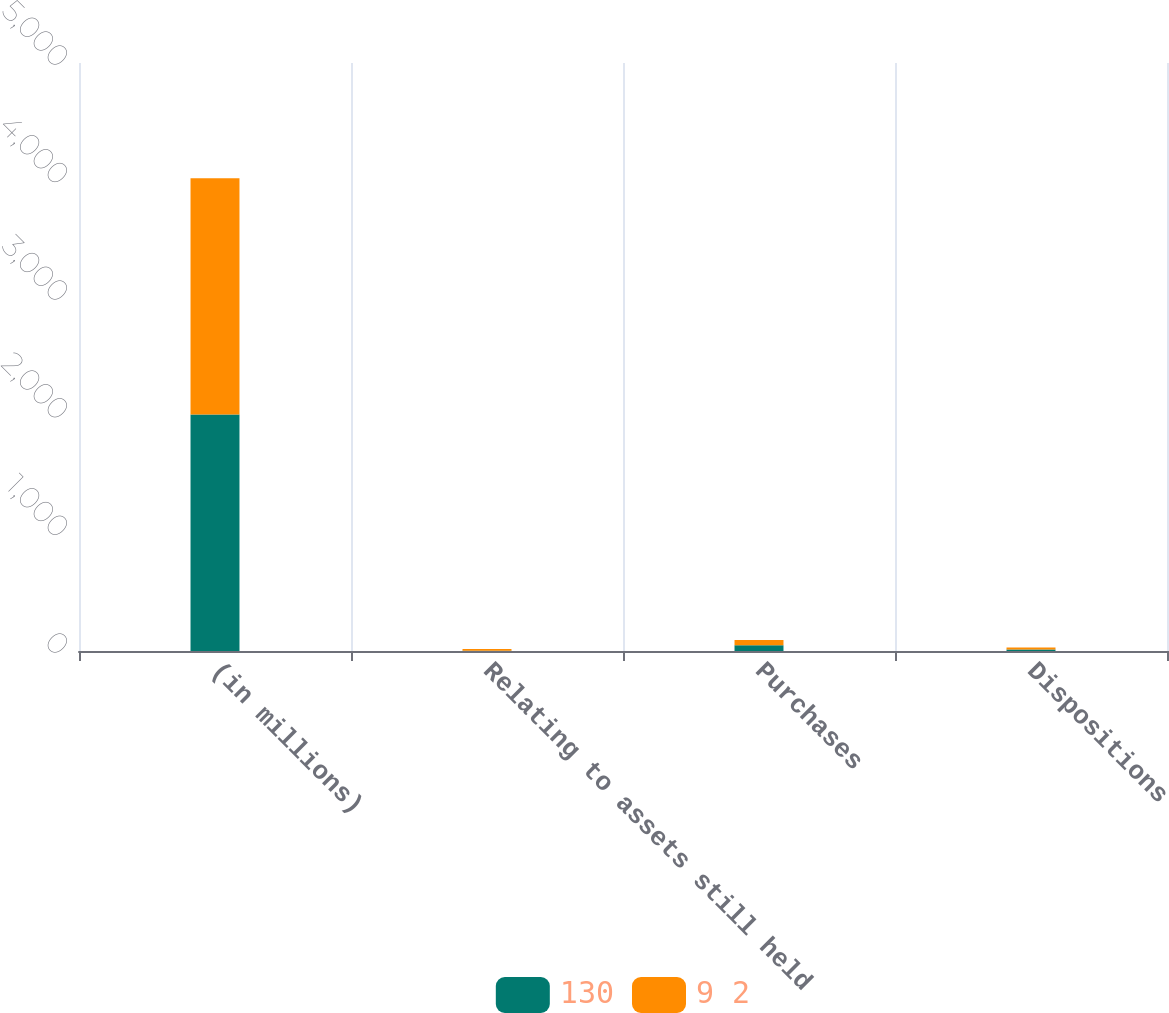Convert chart to OTSL. <chart><loc_0><loc_0><loc_500><loc_500><stacked_bar_chart><ecel><fcel>(in millions)<fcel>Relating to assets still held<fcel>Purchases<fcel>Dispositions<nl><fcel>130<fcel>2011<fcel>3<fcel>48<fcel>13<nl><fcel>9 2<fcel>2010<fcel>14<fcel>46<fcel>17<nl></chart> 